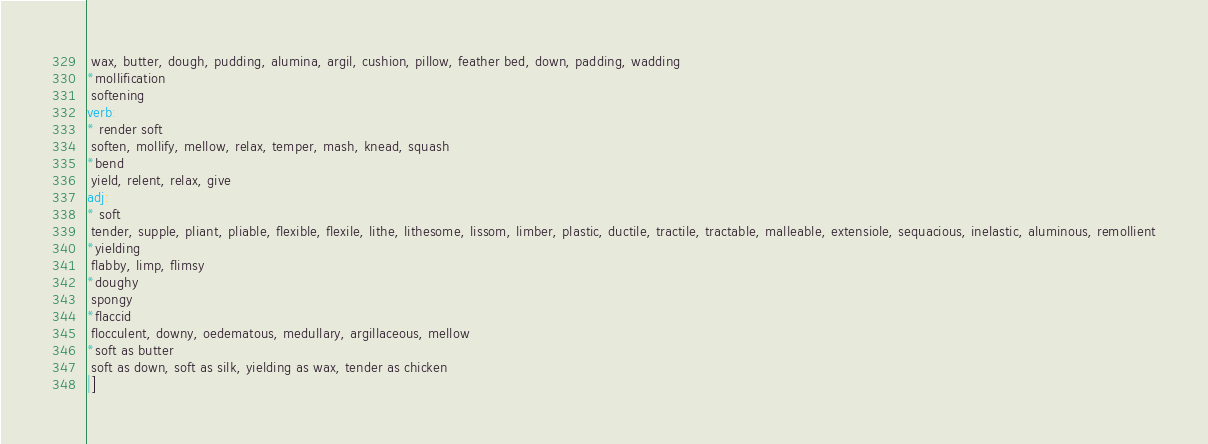Convert code to text. <code><loc_0><loc_0><loc_500><loc_500><_Haskell_> wax, butter, dough, pudding, alumina, argil, cushion, pillow, feather bed, down, padding, wadding
*mollification
 softening
verb:
* render soft
 soften, mollify, mellow, relax, temper, mash, knead, squash
*bend
 yield, relent, relax, give
adj:
* soft
 tender, supple, pliant, pliable, flexible, flexile, lithe, lithesome, lissom, limber, plastic, ductile, tractile, tractable, malleable, extensiole, sequacious, inelastic, aluminous, remollient
*yielding
 flabby, limp, flimsy
*doughy
 spongy
*flaccid
 flocculent, downy, oedematous, medullary, argillaceous, mellow
*soft as butter
 soft as down, soft as silk, yielding as wax, tender as chicken
|]
</code> 